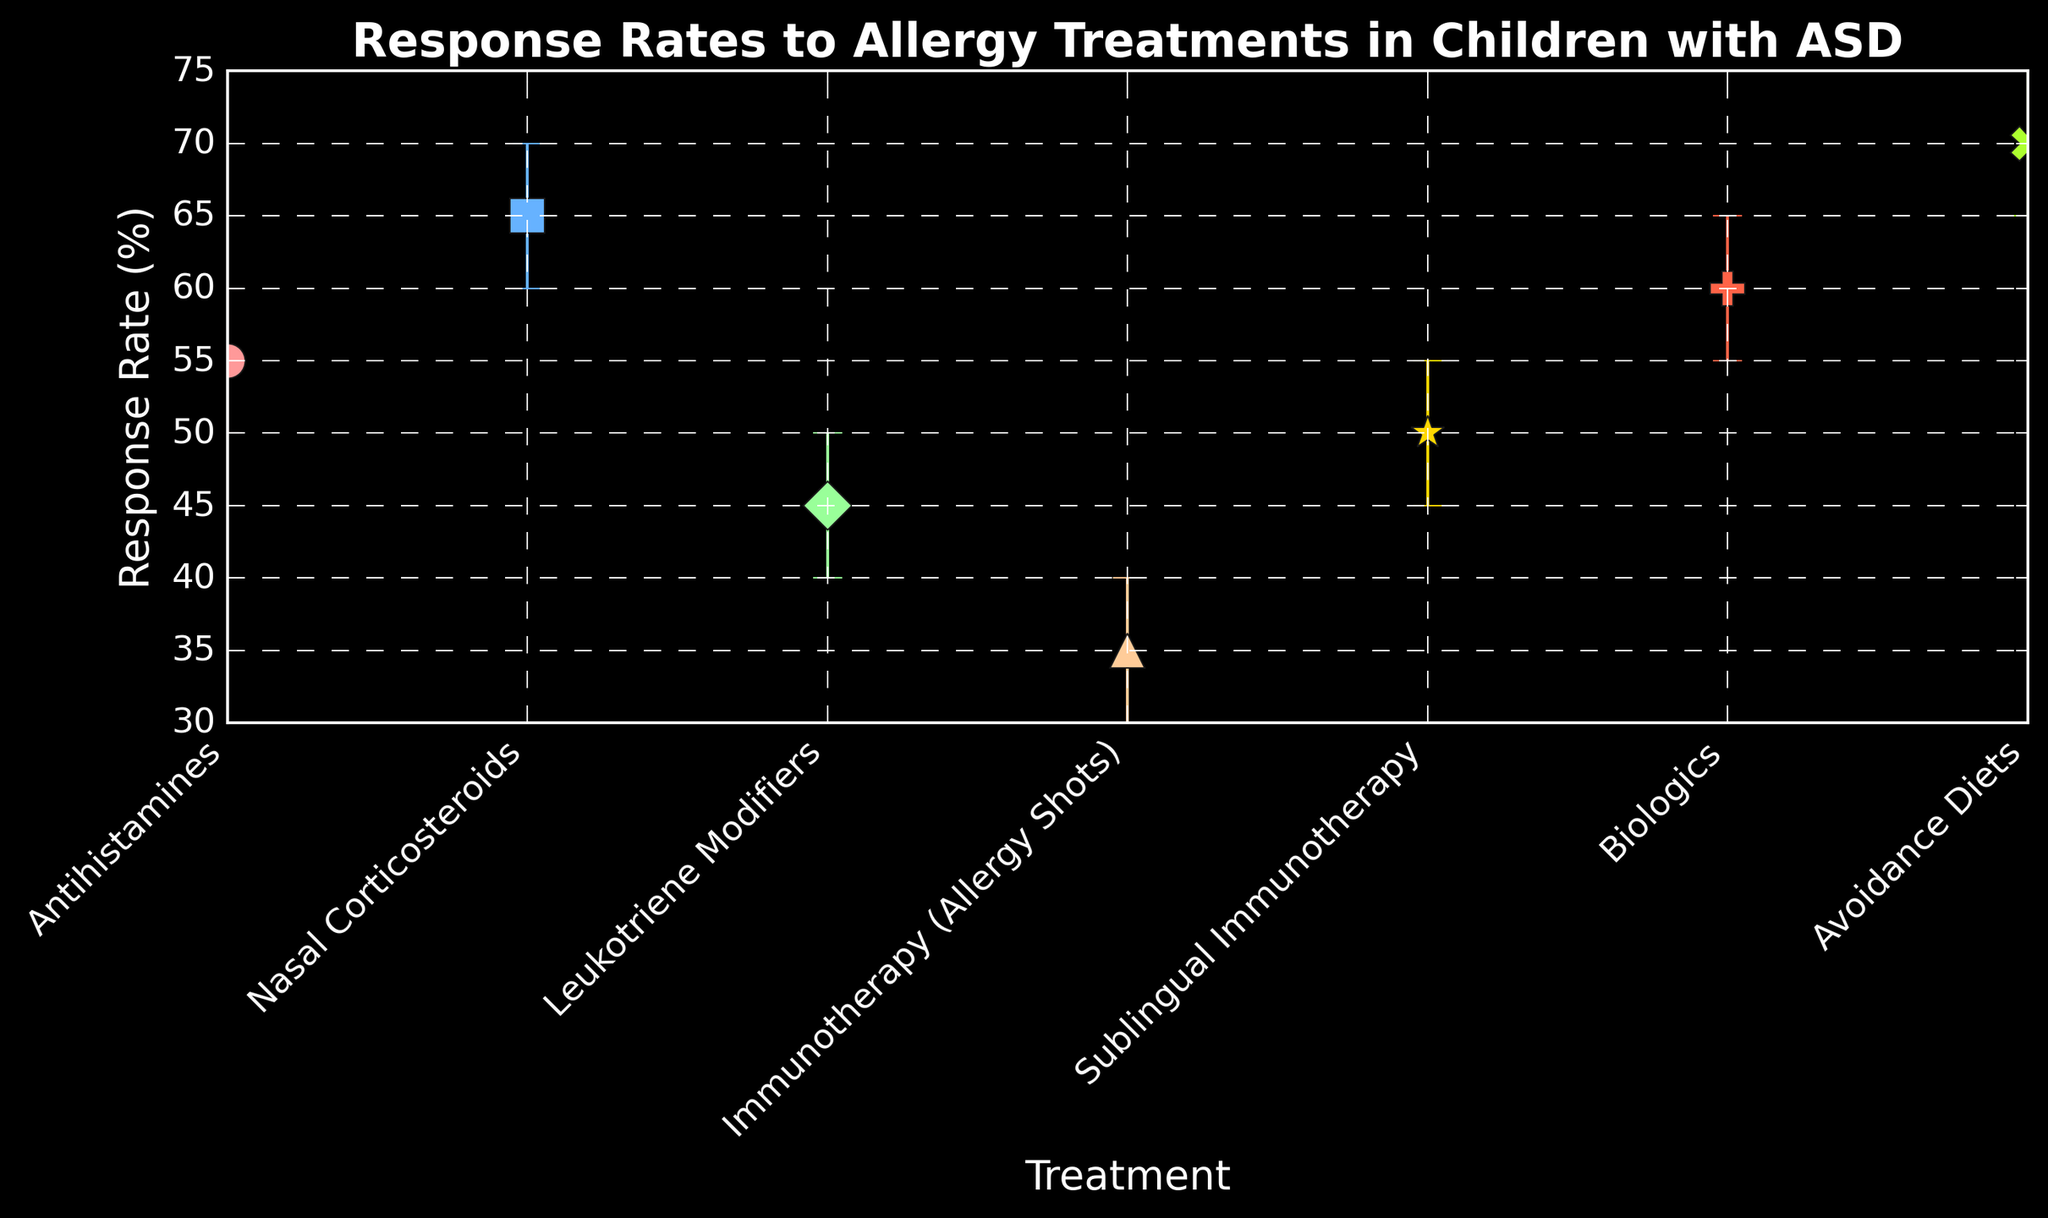What's the average response rate of all treatments? To find the average, sum all the response rates and divide by the number of treatments. Sum = 55 + 65 + 45 + 35 + 50 + 60 + 70 = 380. Number of treatments = 7. Average = 380 / 7 = 54.29
Answer: 54.29 Which treatment has the highest response rate? Compare the response rates of all treatments. The highest response rate is 70%, which is for Avoidance Diets.
Answer: Avoidance Diets What is the difference in response rate between Immunotherapy (Allergy Shots) and Nasal Corticosteroids? Subtract the response rate of Immunotherapy (35%) from Nasal Corticosteroids (65%). Difference = 65 - 35 = 30
Answer: 30 Which treatment has the smallest confidence interval range? Calculate the range for each treatment by subtracting the lower CI from the upper CI and find the smallest. All treatments have a range of 10%. Therefore, any treatment can be stated, e.g., Antihistamines.
Answer: 10% Which treatments have overlapping confidence intervals with Antihistamines? Antihistamines have a CI range of 50-60. Check for other treatments whose CI ranges overlap with this range. Sublingual Immunotherapy (45-55), Nasal Corticosteroids (60-70), and Leukotriene Modifiers (40-50) overlap with Antihistamines.
Answer: Sublingual Immunotherapy, Nasal Corticosteroids, Leukotriene Modifiers Compare the response rates between Sublingual Immunotherapy and Biologics. Which is higher and by how much? Sublingual Immunotherapy response rate is 50%, and Biologics is 60%. The difference is 60 - 50 = 10%, so Biologics is higher by 10%.
Answer: Biologics, 10% What is the median response rate of the treatments? Arrange response rates in ascending order: 35, 45, 50, 55, 60, 65, 70. The median is the middle value, which is 55.
Answer: 55 Which treatment has the widest confidence interval? All treatments have the same confidence interval range (50-60, 60-70, 40-50, etc.), which is 10%. Therefore, there is no single treatment with the widest confidence interval, they all are the same.
Answer: All treatments (equal) What is the sum of the lower confidence intervals for all treatments? Sum the lower CI values: 50 + 60 + 40 + 30 + 45 + 55 + 65 = 345.
Answer: 345 Which treatment has the lowest response rate and what is it? Compare the response rates of all treatments. Immunotherapy (Allergy Shots) has the lowest response rate at 35%.
Answer: Immunotherapy (Allergy Shots), 35% 